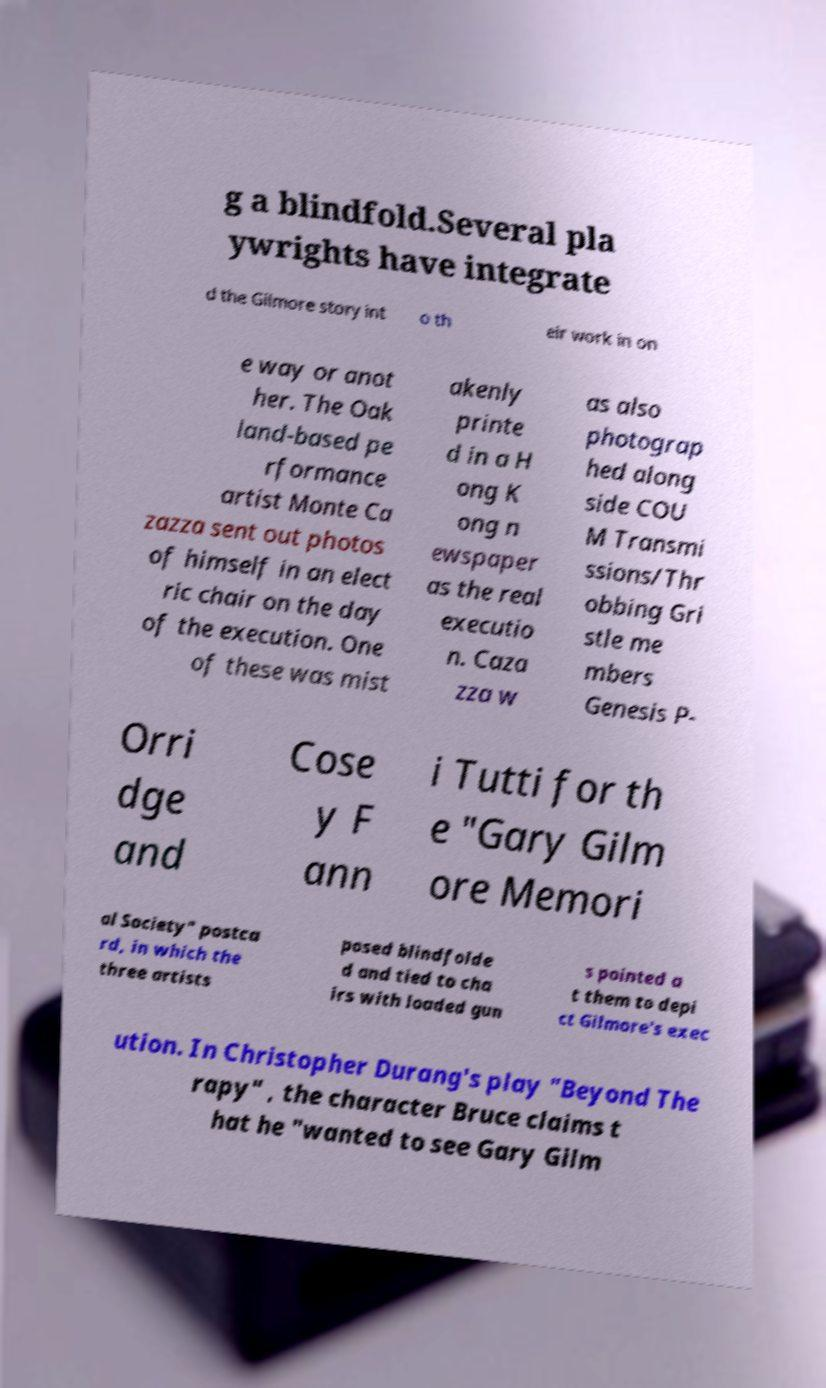I need the written content from this picture converted into text. Can you do that? g a blindfold.Several pla ywrights have integrate d the Gilmore story int o th eir work in on e way or anot her. The Oak land-based pe rformance artist Monte Ca zazza sent out photos of himself in an elect ric chair on the day of the execution. One of these was mist akenly printe d in a H ong K ong n ewspaper as the real executio n. Caza zza w as also photograp hed along side COU M Transmi ssions/Thr obbing Gri stle me mbers Genesis P- Orri dge and Cose y F ann i Tutti for th e "Gary Gilm ore Memori al Society" postca rd, in which the three artists posed blindfolde d and tied to cha irs with loaded gun s pointed a t them to depi ct Gilmore's exec ution. In Christopher Durang's play "Beyond The rapy" , the character Bruce claims t hat he "wanted to see Gary Gilm 